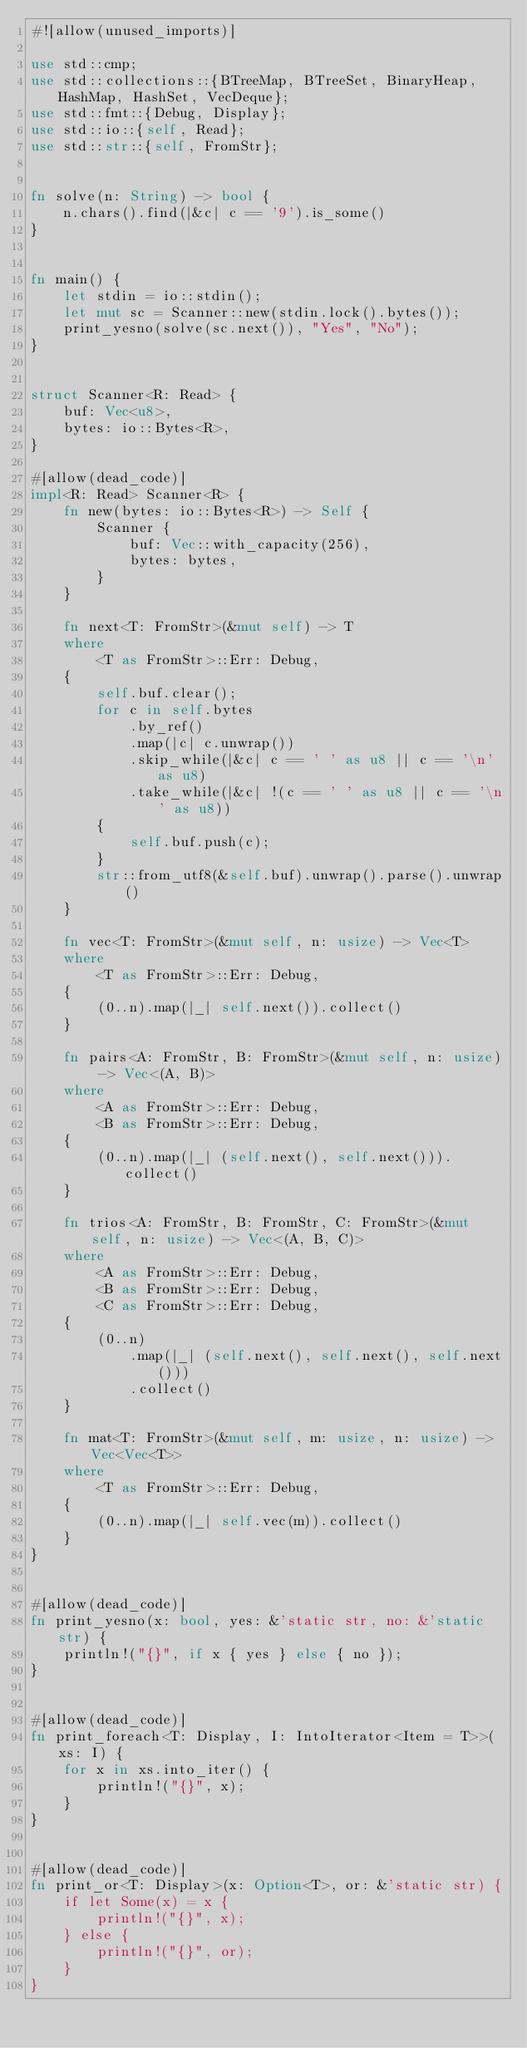<code> <loc_0><loc_0><loc_500><loc_500><_Rust_>#![allow(unused_imports)]

use std::cmp;
use std::collections::{BTreeMap, BTreeSet, BinaryHeap, HashMap, HashSet, VecDeque};
use std::fmt::{Debug, Display};
use std::io::{self, Read};
use std::str::{self, FromStr};


fn solve(n: String) -> bool {
    n.chars().find(|&c| c == '9').is_some()
}


fn main() {
    let stdin = io::stdin();
    let mut sc = Scanner::new(stdin.lock().bytes());
    print_yesno(solve(sc.next()), "Yes", "No");
}


struct Scanner<R: Read> {
    buf: Vec<u8>,
    bytes: io::Bytes<R>,
}

#[allow(dead_code)]
impl<R: Read> Scanner<R> {
    fn new(bytes: io::Bytes<R>) -> Self {
        Scanner {
            buf: Vec::with_capacity(256),
            bytes: bytes,
        }
    }

    fn next<T: FromStr>(&mut self) -> T
    where
        <T as FromStr>::Err: Debug,
    {
        self.buf.clear();
        for c in self.bytes
            .by_ref()
            .map(|c| c.unwrap())
            .skip_while(|&c| c == ' ' as u8 || c == '\n' as u8)
            .take_while(|&c| !(c == ' ' as u8 || c == '\n' as u8))
        {
            self.buf.push(c);
        }
        str::from_utf8(&self.buf).unwrap().parse().unwrap()
    }

    fn vec<T: FromStr>(&mut self, n: usize) -> Vec<T>
    where
        <T as FromStr>::Err: Debug,
    {
        (0..n).map(|_| self.next()).collect()
    }

    fn pairs<A: FromStr, B: FromStr>(&mut self, n: usize) -> Vec<(A, B)>
    where
        <A as FromStr>::Err: Debug,
        <B as FromStr>::Err: Debug,
    {
        (0..n).map(|_| (self.next(), self.next())).collect()
    }

    fn trios<A: FromStr, B: FromStr, C: FromStr>(&mut self, n: usize) -> Vec<(A, B, C)>
    where
        <A as FromStr>::Err: Debug,
        <B as FromStr>::Err: Debug,
        <C as FromStr>::Err: Debug,
    {
        (0..n)
            .map(|_| (self.next(), self.next(), self.next()))
            .collect()
    }

    fn mat<T: FromStr>(&mut self, m: usize, n: usize) -> Vec<Vec<T>>
    where
        <T as FromStr>::Err: Debug,
    {
        (0..n).map(|_| self.vec(m)).collect()
    }
}


#[allow(dead_code)]
fn print_yesno(x: bool, yes: &'static str, no: &'static str) {
    println!("{}", if x { yes } else { no });
}


#[allow(dead_code)]
fn print_foreach<T: Display, I: IntoIterator<Item = T>>(xs: I) {
    for x in xs.into_iter() {
        println!("{}", x);
    }
}


#[allow(dead_code)]
fn print_or<T: Display>(x: Option<T>, or: &'static str) {
    if let Some(x) = x {
        println!("{}", x);
    } else {
        println!("{}", or);
    }
}
</code> 